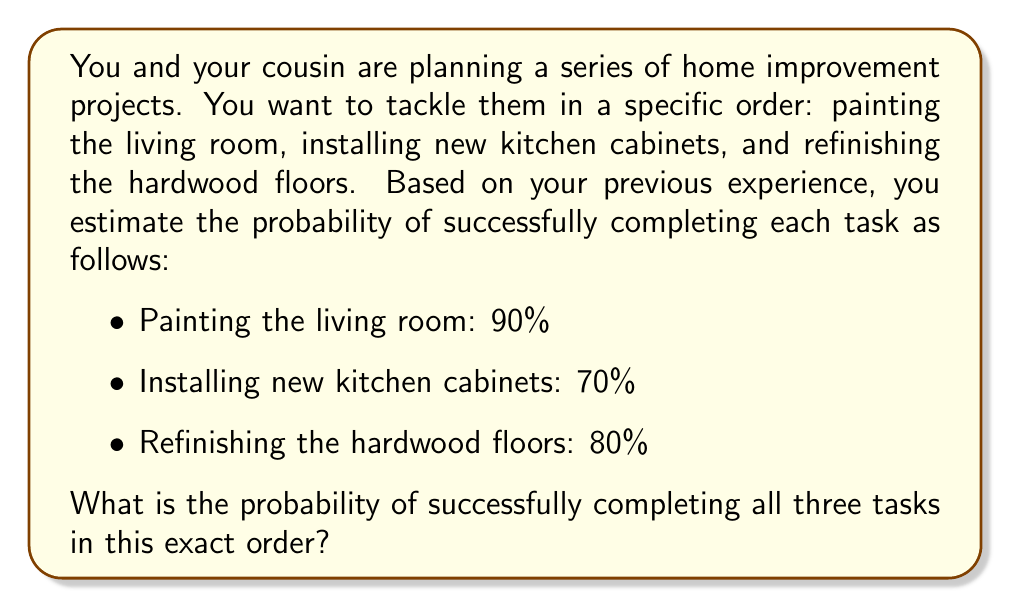Give your solution to this math problem. To solve this problem, we need to use the concept of independent events and the multiplication rule of probability.

Step 1: Identify the probabilities for each task
Let's define:
$P(A)$ = Probability of successfully painting the living room = 0.90
$P(B)$ = Probability of successfully installing new kitchen cabinets = 0.70
$P(C)$ = Probability of successfully refinishing the hardwood floors = 0.80

Step 2: Apply the multiplication rule of probability
Since we want to complete all tasks successfully in this specific order, we need to multiply the individual probabilities:

$$P(\text{All tasks successful}) = P(A) \times P(B) \times P(C)$$

Step 3: Calculate the final probability
$$P(\text{All tasks successful}) = 0.90 \times 0.70 \times 0.80$$
$$P(\text{All tasks successful}) = 0.504$$

Step 4: Convert to percentage (optional)
$$0.504 \times 100\% = 50.4\%$$

Therefore, the probability of successfully completing all three tasks in the specified order is 0.504 or 50.4%.
Answer: 0.504 